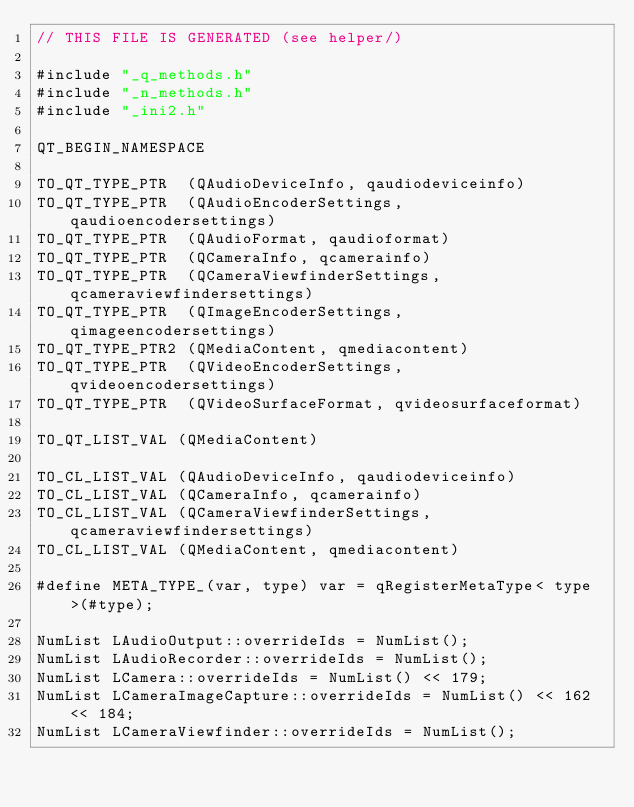<code> <loc_0><loc_0><loc_500><loc_500><_C++_>// THIS FILE IS GENERATED (see helper/)

#include "_q_methods.h"
#include "_n_methods.h"
#include "_ini2.h"

QT_BEGIN_NAMESPACE

TO_QT_TYPE_PTR  (QAudioDeviceInfo, qaudiodeviceinfo)
TO_QT_TYPE_PTR  (QAudioEncoderSettings, qaudioencodersettings)
TO_QT_TYPE_PTR  (QAudioFormat, qaudioformat)
TO_QT_TYPE_PTR  (QCameraInfo, qcamerainfo)
TO_QT_TYPE_PTR  (QCameraViewfinderSettings, qcameraviewfindersettings)
TO_QT_TYPE_PTR  (QImageEncoderSettings, qimageencodersettings)
TO_QT_TYPE_PTR2 (QMediaContent, qmediacontent)
TO_QT_TYPE_PTR  (QVideoEncoderSettings, qvideoencodersettings)
TO_QT_TYPE_PTR  (QVideoSurfaceFormat, qvideosurfaceformat)

TO_QT_LIST_VAL (QMediaContent)

TO_CL_LIST_VAL (QAudioDeviceInfo, qaudiodeviceinfo)
TO_CL_LIST_VAL (QCameraInfo, qcamerainfo)
TO_CL_LIST_VAL (QCameraViewfinderSettings, qcameraviewfindersettings)
TO_CL_LIST_VAL (QMediaContent, qmediacontent)

#define META_TYPE_(var, type) var = qRegisterMetaType< type >(#type);

NumList LAudioOutput::overrideIds = NumList();
NumList LAudioRecorder::overrideIds = NumList();
NumList LCamera::overrideIds = NumList() << 179;
NumList LCameraImageCapture::overrideIds = NumList() << 162 << 184;
NumList LCameraViewfinder::overrideIds = NumList();</code> 